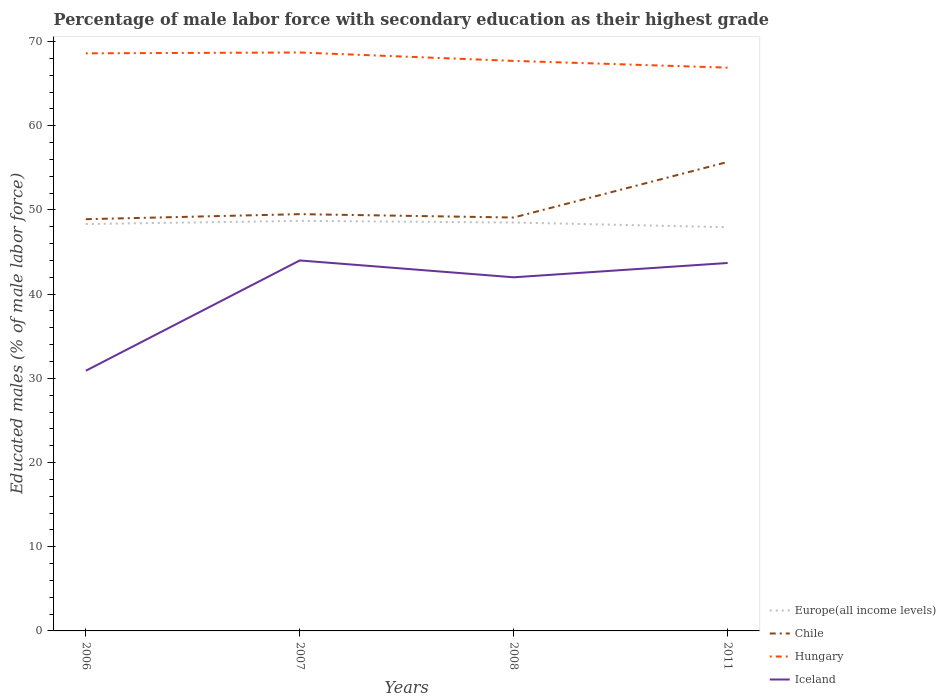Across all years, what is the maximum percentage of male labor force with secondary education in Chile?
Offer a terse response. 48.9. In which year was the percentage of male labor force with secondary education in Europe(all income levels) maximum?
Keep it short and to the point. 2011. What is the total percentage of male labor force with secondary education in Hungary in the graph?
Your response must be concise. 1.8. What is the difference between the highest and the second highest percentage of male labor force with secondary education in Hungary?
Keep it short and to the point. 1.8. What is the difference between the highest and the lowest percentage of male labor force with secondary education in Hungary?
Your response must be concise. 2. How many lines are there?
Your answer should be compact. 4. How many years are there in the graph?
Ensure brevity in your answer.  4. What is the difference between two consecutive major ticks on the Y-axis?
Make the answer very short. 10. Does the graph contain any zero values?
Provide a succinct answer. No. How are the legend labels stacked?
Provide a short and direct response. Vertical. What is the title of the graph?
Your response must be concise. Percentage of male labor force with secondary education as their highest grade. What is the label or title of the X-axis?
Provide a succinct answer. Years. What is the label or title of the Y-axis?
Give a very brief answer. Educated males (% of male labor force). What is the Educated males (% of male labor force) of Europe(all income levels) in 2006?
Keep it short and to the point. 48.33. What is the Educated males (% of male labor force) in Chile in 2006?
Your response must be concise. 48.9. What is the Educated males (% of male labor force) in Hungary in 2006?
Your response must be concise. 68.6. What is the Educated males (% of male labor force) in Iceland in 2006?
Your answer should be very brief. 30.9. What is the Educated males (% of male labor force) in Europe(all income levels) in 2007?
Make the answer very short. 48.7. What is the Educated males (% of male labor force) of Chile in 2007?
Ensure brevity in your answer.  49.5. What is the Educated males (% of male labor force) of Hungary in 2007?
Provide a succinct answer. 68.7. What is the Educated males (% of male labor force) in Iceland in 2007?
Make the answer very short. 44. What is the Educated males (% of male labor force) in Europe(all income levels) in 2008?
Your answer should be very brief. 48.51. What is the Educated males (% of male labor force) in Chile in 2008?
Keep it short and to the point. 49.1. What is the Educated males (% of male labor force) in Hungary in 2008?
Your answer should be very brief. 67.7. What is the Educated males (% of male labor force) in Iceland in 2008?
Keep it short and to the point. 42. What is the Educated males (% of male labor force) in Europe(all income levels) in 2011?
Offer a terse response. 47.95. What is the Educated males (% of male labor force) of Chile in 2011?
Provide a succinct answer. 55.7. What is the Educated males (% of male labor force) of Hungary in 2011?
Ensure brevity in your answer.  66.9. What is the Educated males (% of male labor force) in Iceland in 2011?
Provide a short and direct response. 43.7. Across all years, what is the maximum Educated males (% of male labor force) of Europe(all income levels)?
Provide a short and direct response. 48.7. Across all years, what is the maximum Educated males (% of male labor force) of Chile?
Keep it short and to the point. 55.7. Across all years, what is the maximum Educated males (% of male labor force) of Hungary?
Offer a terse response. 68.7. Across all years, what is the minimum Educated males (% of male labor force) in Europe(all income levels)?
Keep it short and to the point. 47.95. Across all years, what is the minimum Educated males (% of male labor force) in Chile?
Offer a terse response. 48.9. Across all years, what is the minimum Educated males (% of male labor force) in Hungary?
Offer a very short reply. 66.9. Across all years, what is the minimum Educated males (% of male labor force) in Iceland?
Offer a terse response. 30.9. What is the total Educated males (% of male labor force) of Europe(all income levels) in the graph?
Provide a short and direct response. 193.48. What is the total Educated males (% of male labor force) of Chile in the graph?
Give a very brief answer. 203.2. What is the total Educated males (% of male labor force) of Hungary in the graph?
Offer a very short reply. 271.9. What is the total Educated males (% of male labor force) in Iceland in the graph?
Your response must be concise. 160.6. What is the difference between the Educated males (% of male labor force) in Europe(all income levels) in 2006 and that in 2007?
Provide a short and direct response. -0.37. What is the difference between the Educated males (% of male labor force) in Chile in 2006 and that in 2007?
Give a very brief answer. -0.6. What is the difference between the Educated males (% of male labor force) in Iceland in 2006 and that in 2007?
Ensure brevity in your answer.  -13.1. What is the difference between the Educated males (% of male labor force) of Europe(all income levels) in 2006 and that in 2008?
Offer a terse response. -0.18. What is the difference between the Educated males (% of male labor force) in Hungary in 2006 and that in 2008?
Your response must be concise. 0.9. What is the difference between the Educated males (% of male labor force) of Europe(all income levels) in 2006 and that in 2011?
Your answer should be compact. 0.38. What is the difference between the Educated males (% of male labor force) of Europe(all income levels) in 2007 and that in 2008?
Your answer should be compact. 0.19. What is the difference between the Educated males (% of male labor force) in Chile in 2007 and that in 2008?
Your answer should be compact. 0.4. What is the difference between the Educated males (% of male labor force) of Iceland in 2007 and that in 2008?
Offer a very short reply. 2. What is the difference between the Educated males (% of male labor force) of Europe(all income levels) in 2007 and that in 2011?
Offer a terse response. 0.76. What is the difference between the Educated males (% of male labor force) of Chile in 2007 and that in 2011?
Your answer should be compact. -6.2. What is the difference between the Educated males (% of male labor force) in Europe(all income levels) in 2008 and that in 2011?
Your answer should be very brief. 0.56. What is the difference between the Educated males (% of male labor force) in Europe(all income levels) in 2006 and the Educated males (% of male labor force) in Chile in 2007?
Offer a very short reply. -1.17. What is the difference between the Educated males (% of male labor force) in Europe(all income levels) in 2006 and the Educated males (% of male labor force) in Hungary in 2007?
Your answer should be very brief. -20.37. What is the difference between the Educated males (% of male labor force) in Europe(all income levels) in 2006 and the Educated males (% of male labor force) in Iceland in 2007?
Provide a short and direct response. 4.33. What is the difference between the Educated males (% of male labor force) in Chile in 2006 and the Educated males (% of male labor force) in Hungary in 2007?
Give a very brief answer. -19.8. What is the difference between the Educated males (% of male labor force) of Chile in 2006 and the Educated males (% of male labor force) of Iceland in 2007?
Offer a very short reply. 4.9. What is the difference between the Educated males (% of male labor force) of Hungary in 2006 and the Educated males (% of male labor force) of Iceland in 2007?
Your response must be concise. 24.6. What is the difference between the Educated males (% of male labor force) in Europe(all income levels) in 2006 and the Educated males (% of male labor force) in Chile in 2008?
Provide a succinct answer. -0.77. What is the difference between the Educated males (% of male labor force) of Europe(all income levels) in 2006 and the Educated males (% of male labor force) of Hungary in 2008?
Offer a terse response. -19.37. What is the difference between the Educated males (% of male labor force) in Europe(all income levels) in 2006 and the Educated males (% of male labor force) in Iceland in 2008?
Your answer should be very brief. 6.33. What is the difference between the Educated males (% of male labor force) in Chile in 2006 and the Educated males (% of male labor force) in Hungary in 2008?
Your response must be concise. -18.8. What is the difference between the Educated males (% of male labor force) in Chile in 2006 and the Educated males (% of male labor force) in Iceland in 2008?
Offer a very short reply. 6.9. What is the difference between the Educated males (% of male labor force) in Hungary in 2006 and the Educated males (% of male labor force) in Iceland in 2008?
Give a very brief answer. 26.6. What is the difference between the Educated males (% of male labor force) of Europe(all income levels) in 2006 and the Educated males (% of male labor force) of Chile in 2011?
Keep it short and to the point. -7.37. What is the difference between the Educated males (% of male labor force) in Europe(all income levels) in 2006 and the Educated males (% of male labor force) in Hungary in 2011?
Give a very brief answer. -18.57. What is the difference between the Educated males (% of male labor force) of Europe(all income levels) in 2006 and the Educated males (% of male labor force) of Iceland in 2011?
Provide a succinct answer. 4.63. What is the difference between the Educated males (% of male labor force) in Chile in 2006 and the Educated males (% of male labor force) in Iceland in 2011?
Keep it short and to the point. 5.2. What is the difference between the Educated males (% of male labor force) of Hungary in 2006 and the Educated males (% of male labor force) of Iceland in 2011?
Ensure brevity in your answer.  24.9. What is the difference between the Educated males (% of male labor force) of Europe(all income levels) in 2007 and the Educated males (% of male labor force) of Chile in 2008?
Offer a terse response. -0.4. What is the difference between the Educated males (% of male labor force) in Europe(all income levels) in 2007 and the Educated males (% of male labor force) in Hungary in 2008?
Make the answer very short. -19. What is the difference between the Educated males (% of male labor force) in Europe(all income levels) in 2007 and the Educated males (% of male labor force) in Iceland in 2008?
Your response must be concise. 6.7. What is the difference between the Educated males (% of male labor force) in Chile in 2007 and the Educated males (% of male labor force) in Hungary in 2008?
Give a very brief answer. -18.2. What is the difference between the Educated males (% of male labor force) of Hungary in 2007 and the Educated males (% of male labor force) of Iceland in 2008?
Make the answer very short. 26.7. What is the difference between the Educated males (% of male labor force) in Europe(all income levels) in 2007 and the Educated males (% of male labor force) in Chile in 2011?
Keep it short and to the point. -7. What is the difference between the Educated males (% of male labor force) in Europe(all income levels) in 2007 and the Educated males (% of male labor force) in Hungary in 2011?
Provide a succinct answer. -18.2. What is the difference between the Educated males (% of male labor force) in Europe(all income levels) in 2007 and the Educated males (% of male labor force) in Iceland in 2011?
Offer a terse response. 5. What is the difference between the Educated males (% of male labor force) of Chile in 2007 and the Educated males (% of male labor force) of Hungary in 2011?
Provide a short and direct response. -17.4. What is the difference between the Educated males (% of male labor force) in Europe(all income levels) in 2008 and the Educated males (% of male labor force) in Chile in 2011?
Give a very brief answer. -7.19. What is the difference between the Educated males (% of male labor force) in Europe(all income levels) in 2008 and the Educated males (% of male labor force) in Hungary in 2011?
Offer a terse response. -18.39. What is the difference between the Educated males (% of male labor force) of Europe(all income levels) in 2008 and the Educated males (% of male labor force) of Iceland in 2011?
Your answer should be very brief. 4.81. What is the difference between the Educated males (% of male labor force) in Chile in 2008 and the Educated males (% of male labor force) in Hungary in 2011?
Give a very brief answer. -17.8. What is the difference between the Educated males (% of male labor force) of Chile in 2008 and the Educated males (% of male labor force) of Iceland in 2011?
Provide a short and direct response. 5.4. What is the difference between the Educated males (% of male labor force) of Hungary in 2008 and the Educated males (% of male labor force) of Iceland in 2011?
Your response must be concise. 24. What is the average Educated males (% of male labor force) of Europe(all income levels) per year?
Provide a short and direct response. 48.37. What is the average Educated males (% of male labor force) in Chile per year?
Offer a terse response. 50.8. What is the average Educated males (% of male labor force) in Hungary per year?
Offer a terse response. 67.97. What is the average Educated males (% of male labor force) in Iceland per year?
Keep it short and to the point. 40.15. In the year 2006, what is the difference between the Educated males (% of male labor force) in Europe(all income levels) and Educated males (% of male labor force) in Chile?
Make the answer very short. -0.57. In the year 2006, what is the difference between the Educated males (% of male labor force) of Europe(all income levels) and Educated males (% of male labor force) of Hungary?
Your response must be concise. -20.27. In the year 2006, what is the difference between the Educated males (% of male labor force) in Europe(all income levels) and Educated males (% of male labor force) in Iceland?
Give a very brief answer. 17.43. In the year 2006, what is the difference between the Educated males (% of male labor force) in Chile and Educated males (% of male labor force) in Hungary?
Keep it short and to the point. -19.7. In the year 2006, what is the difference between the Educated males (% of male labor force) of Chile and Educated males (% of male labor force) of Iceland?
Your answer should be very brief. 18. In the year 2006, what is the difference between the Educated males (% of male labor force) of Hungary and Educated males (% of male labor force) of Iceland?
Your answer should be very brief. 37.7. In the year 2007, what is the difference between the Educated males (% of male labor force) in Europe(all income levels) and Educated males (% of male labor force) in Chile?
Give a very brief answer. -0.8. In the year 2007, what is the difference between the Educated males (% of male labor force) of Europe(all income levels) and Educated males (% of male labor force) of Hungary?
Provide a short and direct response. -20. In the year 2007, what is the difference between the Educated males (% of male labor force) of Europe(all income levels) and Educated males (% of male labor force) of Iceland?
Your response must be concise. 4.7. In the year 2007, what is the difference between the Educated males (% of male labor force) in Chile and Educated males (% of male labor force) in Hungary?
Your answer should be very brief. -19.2. In the year 2007, what is the difference between the Educated males (% of male labor force) of Chile and Educated males (% of male labor force) of Iceland?
Your answer should be compact. 5.5. In the year 2007, what is the difference between the Educated males (% of male labor force) of Hungary and Educated males (% of male labor force) of Iceland?
Provide a short and direct response. 24.7. In the year 2008, what is the difference between the Educated males (% of male labor force) in Europe(all income levels) and Educated males (% of male labor force) in Chile?
Offer a very short reply. -0.59. In the year 2008, what is the difference between the Educated males (% of male labor force) in Europe(all income levels) and Educated males (% of male labor force) in Hungary?
Offer a very short reply. -19.19. In the year 2008, what is the difference between the Educated males (% of male labor force) in Europe(all income levels) and Educated males (% of male labor force) in Iceland?
Give a very brief answer. 6.51. In the year 2008, what is the difference between the Educated males (% of male labor force) of Chile and Educated males (% of male labor force) of Hungary?
Offer a terse response. -18.6. In the year 2008, what is the difference between the Educated males (% of male labor force) of Hungary and Educated males (% of male labor force) of Iceland?
Provide a succinct answer. 25.7. In the year 2011, what is the difference between the Educated males (% of male labor force) in Europe(all income levels) and Educated males (% of male labor force) in Chile?
Your answer should be very brief. -7.75. In the year 2011, what is the difference between the Educated males (% of male labor force) in Europe(all income levels) and Educated males (% of male labor force) in Hungary?
Provide a short and direct response. -18.95. In the year 2011, what is the difference between the Educated males (% of male labor force) in Europe(all income levels) and Educated males (% of male labor force) in Iceland?
Make the answer very short. 4.25. In the year 2011, what is the difference between the Educated males (% of male labor force) of Chile and Educated males (% of male labor force) of Hungary?
Provide a short and direct response. -11.2. In the year 2011, what is the difference between the Educated males (% of male labor force) in Hungary and Educated males (% of male labor force) in Iceland?
Provide a short and direct response. 23.2. What is the ratio of the Educated males (% of male labor force) in Europe(all income levels) in 2006 to that in 2007?
Give a very brief answer. 0.99. What is the ratio of the Educated males (% of male labor force) in Chile in 2006 to that in 2007?
Your answer should be compact. 0.99. What is the ratio of the Educated males (% of male labor force) in Hungary in 2006 to that in 2007?
Provide a succinct answer. 1. What is the ratio of the Educated males (% of male labor force) of Iceland in 2006 to that in 2007?
Keep it short and to the point. 0.7. What is the ratio of the Educated males (% of male labor force) of Chile in 2006 to that in 2008?
Your answer should be very brief. 1. What is the ratio of the Educated males (% of male labor force) in Hungary in 2006 to that in 2008?
Your answer should be compact. 1.01. What is the ratio of the Educated males (% of male labor force) of Iceland in 2006 to that in 2008?
Your answer should be very brief. 0.74. What is the ratio of the Educated males (% of male labor force) in Europe(all income levels) in 2006 to that in 2011?
Offer a terse response. 1.01. What is the ratio of the Educated males (% of male labor force) in Chile in 2006 to that in 2011?
Provide a succinct answer. 0.88. What is the ratio of the Educated males (% of male labor force) in Hungary in 2006 to that in 2011?
Provide a succinct answer. 1.03. What is the ratio of the Educated males (% of male labor force) in Iceland in 2006 to that in 2011?
Your answer should be compact. 0.71. What is the ratio of the Educated males (% of male labor force) of Chile in 2007 to that in 2008?
Offer a very short reply. 1.01. What is the ratio of the Educated males (% of male labor force) of Hungary in 2007 to that in 2008?
Your answer should be very brief. 1.01. What is the ratio of the Educated males (% of male labor force) in Iceland in 2007 to that in 2008?
Give a very brief answer. 1.05. What is the ratio of the Educated males (% of male labor force) of Europe(all income levels) in 2007 to that in 2011?
Your answer should be very brief. 1.02. What is the ratio of the Educated males (% of male labor force) in Chile in 2007 to that in 2011?
Make the answer very short. 0.89. What is the ratio of the Educated males (% of male labor force) of Hungary in 2007 to that in 2011?
Offer a very short reply. 1.03. What is the ratio of the Educated males (% of male labor force) in Europe(all income levels) in 2008 to that in 2011?
Your answer should be compact. 1.01. What is the ratio of the Educated males (% of male labor force) in Chile in 2008 to that in 2011?
Give a very brief answer. 0.88. What is the ratio of the Educated males (% of male labor force) of Iceland in 2008 to that in 2011?
Your response must be concise. 0.96. What is the difference between the highest and the second highest Educated males (% of male labor force) in Europe(all income levels)?
Keep it short and to the point. 0.19. What is the difference between the highest and the second highest Educated males (% of male labor force) in Hungary?
Offer a very short reply. 0.1. What is the difference between the highest and the second highest Educated males (% of male labor force) of Iceland?
Make the answer very short. 0.3. What is the difference between the highest and the lowest Educated males (% of male labor force) of Europe(all income levels)?
Ensure brevity in your answer.  0.76. What is the difference between the highest and the lowest Educated males (% of male labor force) of Chile?
Keep it short and to the point. 6.8. What is the difference between the highest and the lowest Educated males (% of male labor force) of Hungary?
Provide a short and direct response. 1.8. What is the difference between the highest and the lowest Educated males (% of male labor force) of Iceland?
Offer a terse response. 13.1. 